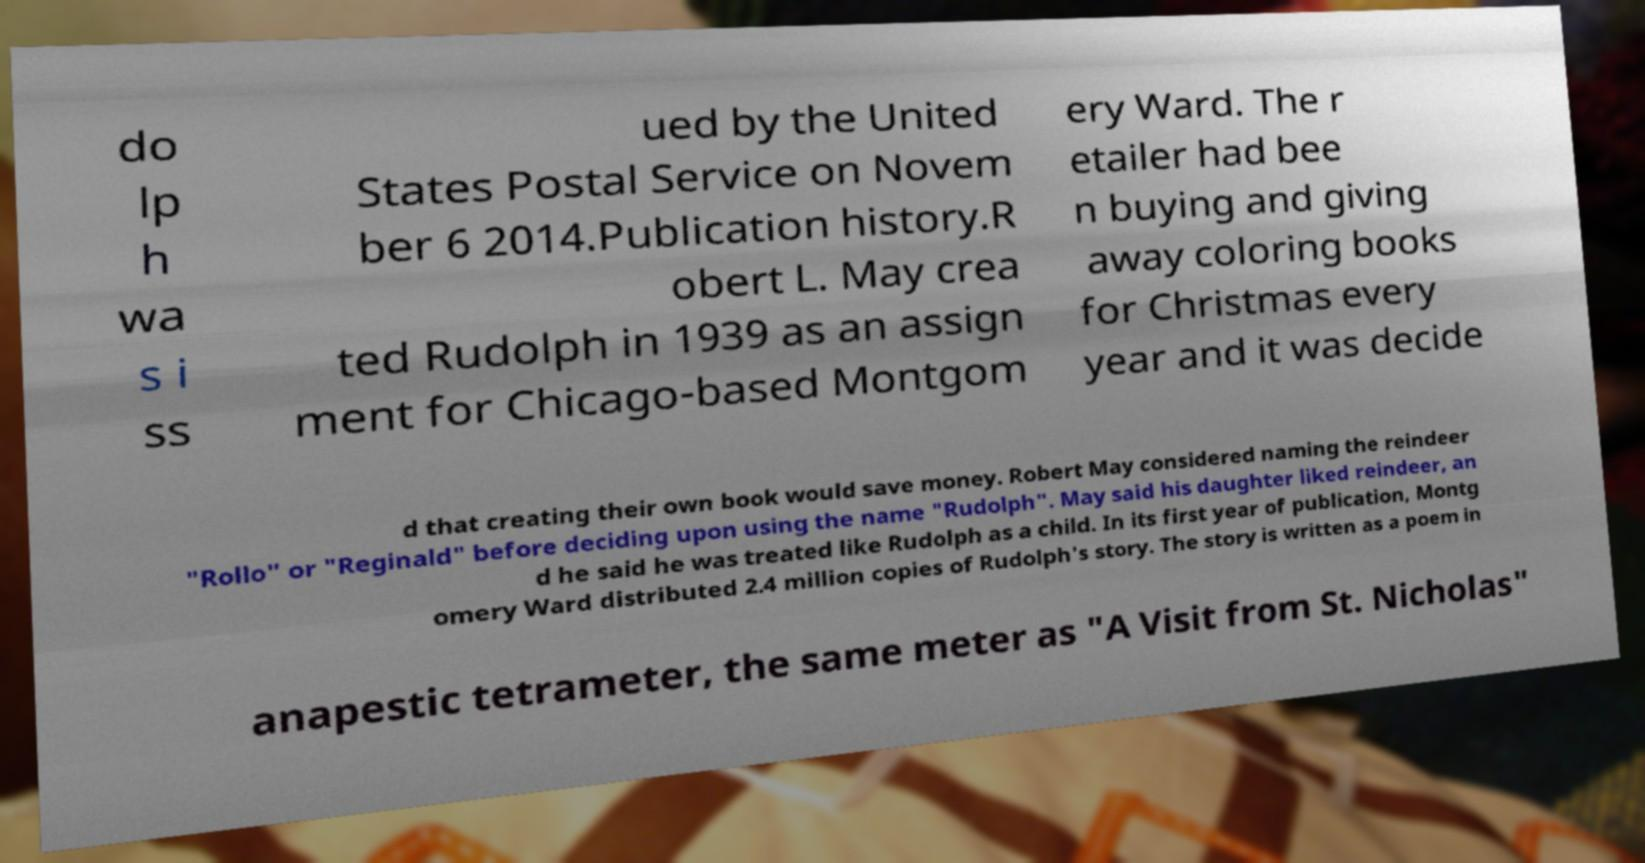What messages or text are displayed in this image? I need them in a readable, typed format. do lp h wa s i ss ued by the United States Postal Service on Novem ber 6 2014.Publication history.R obert L. May crea ted Rudolph in 1939 as an assign ment for Chicago-based Montgom ery Ward. The r etailer had bee n buying and giving away coloring books for Christmas every year and it was decide d that creating their own book would save money. Robert May considered naming the reindeer "Rollo" or "Reginald" before deciding upon using the name "Rudolph". May said his daughter liked reindeer, an d he said he was treated like Rudolph as a child. In its first year of publication, Montg omery Ward distributed 2.4 million copies of Rudolph's story. The story is written as a poem in anapestic tetrameter, the same meter as "A Visit from St. Nicholas" 